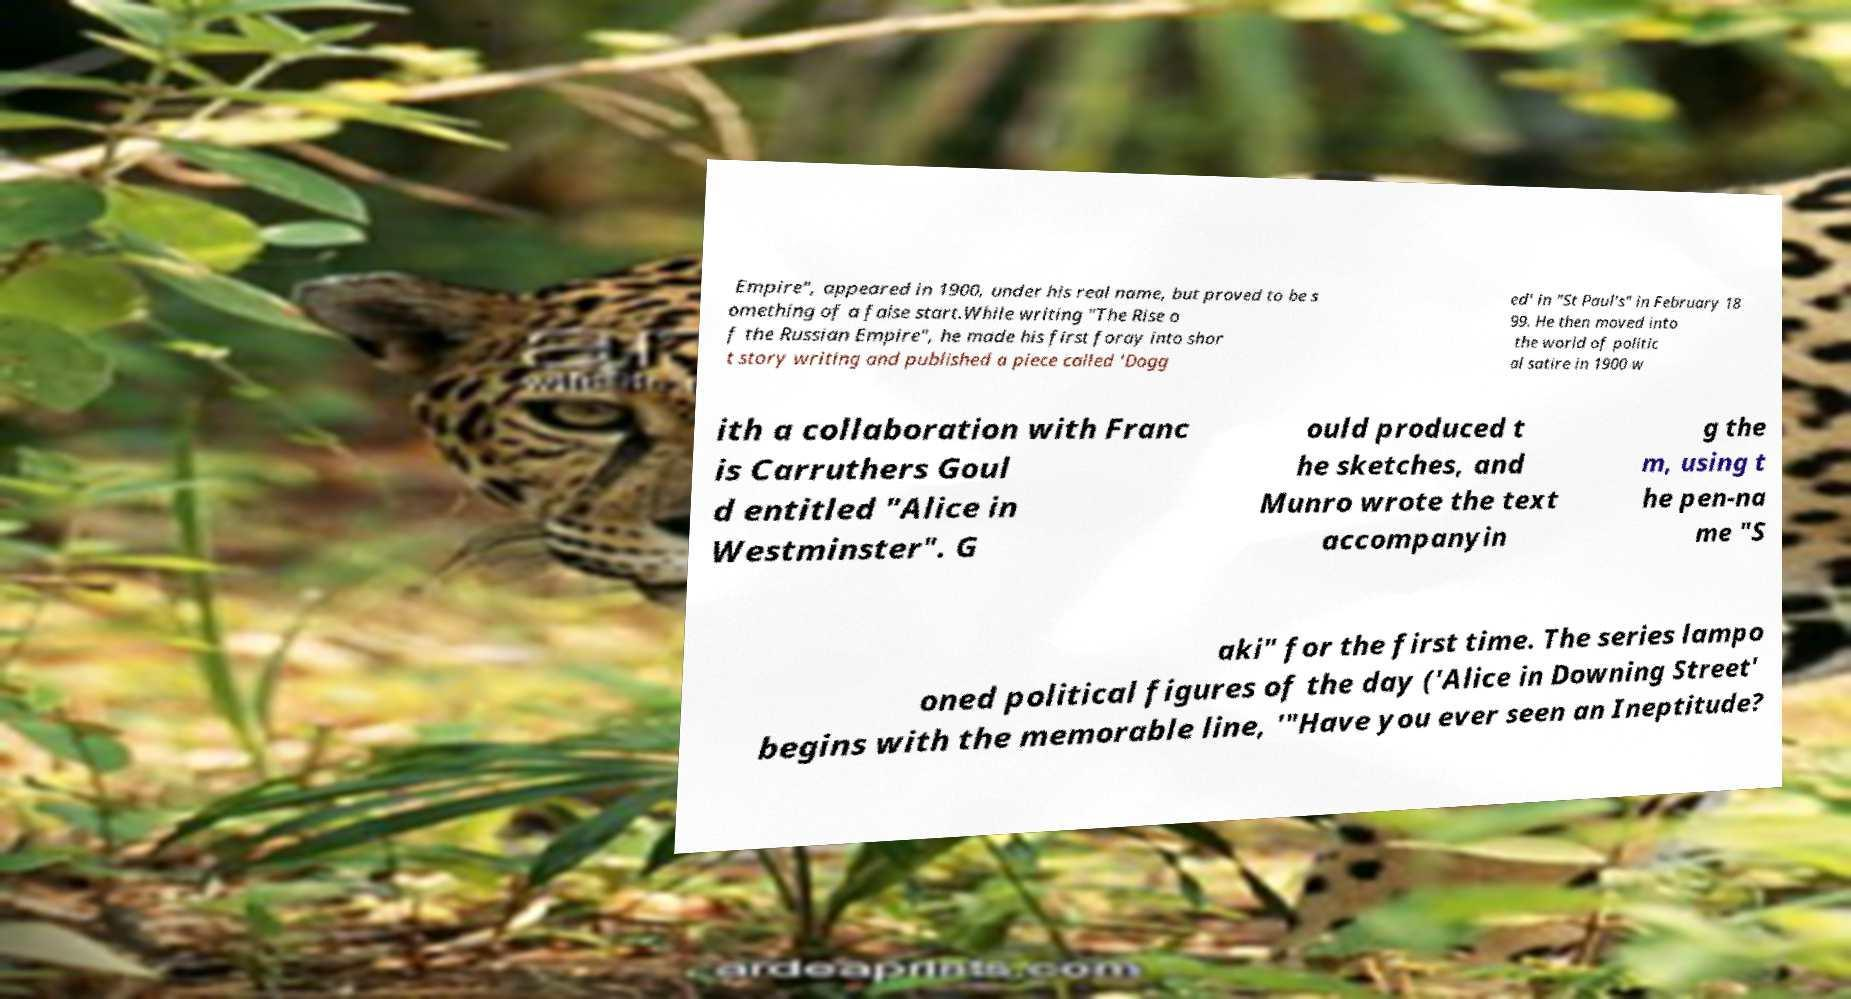Can you accurately transcribe the text from the provided image for me? Empire", appeared in 1900, under his real name, but proved to be s omething of a false start.While writing "The Rise o f the Russian Empire", he made his first foray into shor t story writing and published a piece called 'Dogg ed' in "St Paul's" in February 18 99. He then moved into the world of politic al satire in 1900 w ith a collaboration with Franc is Carruthers Goul d entitled "Alice in Westminster". G ould produced t he sketches, and Munro wrote the text accompanyin g the m, using t he pen-na me "S aki" for the first time. The series lampo oned political figures of the day ('Alice in Downing Street' begins with the memorable line, '"Have you ever seen an Ineptitude? 